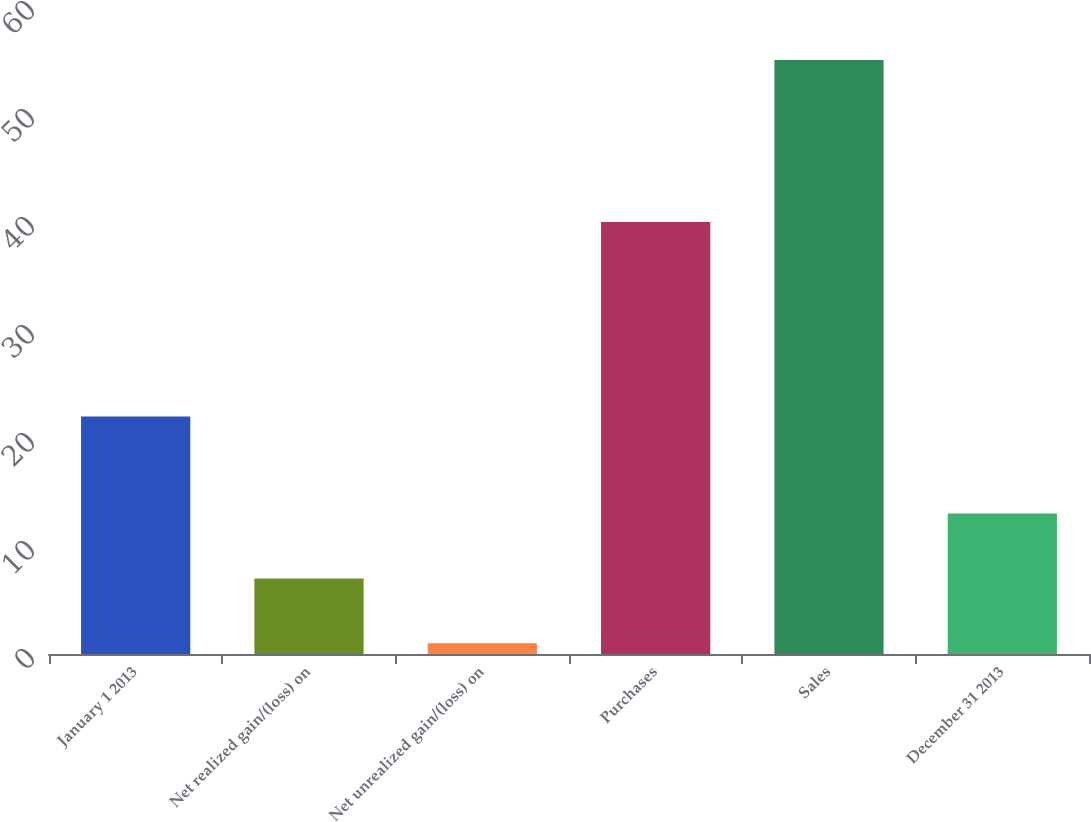Convert chart. <chart><loc_0><loc_0><loc_500><loc_500><bar_chart><fcel>January 1 2013<fcel>Net realized gain/(loss) on<fcel>Net unrealized gain/(loss) on<fcel>Purchases<fcel>Sales<fcel>December 31 2013<nl><fcel>22<fcel>7<fcel>1<fcel>40<fcel>55<fcel>13<nl></chart> 